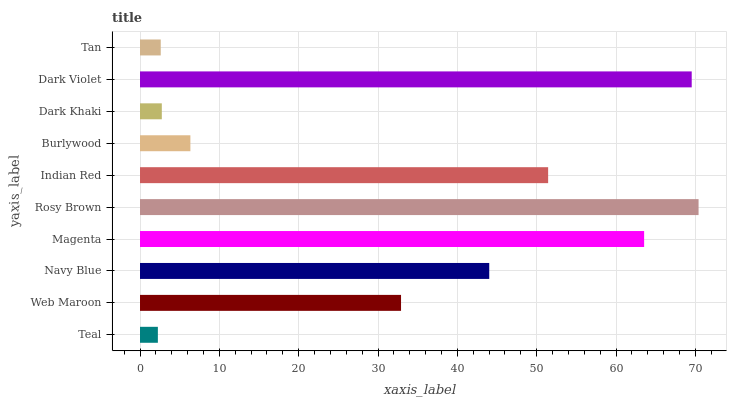Is Teal the minimum?
Answer yes or no. Yes. Is Rosy Brown the maximum?
Answer yes or no. Yes. Is Web Maroon the minimum?
Answer yes or no. No. Is Web Maroon the maximum?
Answer yes or no. No. Is Web Maroon greater than Teal?
Answer yes or no. Yes. Is Teal less than Web Maroon?
Answer yes or no. Yes. Is Teal greater than Web Maroon?
Answer yes or no. No. Is Web Maroon less than Teal?
Answer yes or no. No. Is Navy Blue the high median?
Answer yes or no. Yes. Is Web Maroon the low median?
Answer yes or no. Yes. Is Web Maroon the high median?
Answer yes or no. No. Is Burlywood the low median?
Answer yes or no. No. 